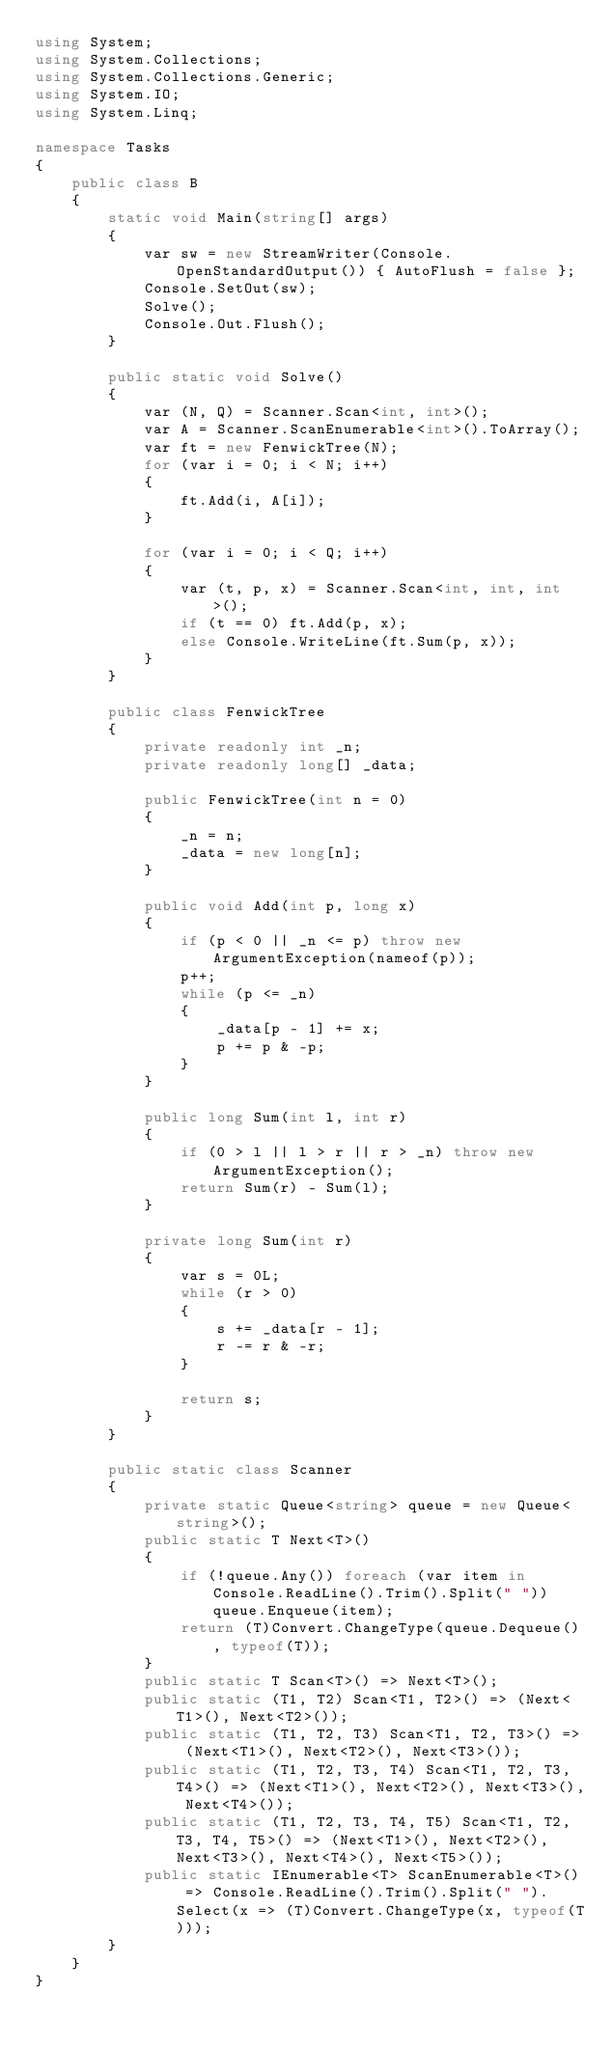<code> <loc_0><loc_0><loc_500><loc_500><_C#_>using System;
using System.Collections;
using System.Collections.Generic;
using System.IO;
using System.Linq;

namespace Tasks
{
    public class B
    {
        static void Main(string[] args)
        {
            var sw = new StreamWriter(Console.OpenStandardOutput()) { AutoFlush = false };
            Console.SetOut(sw);
            Solve();
            Console.Out.Flush();
        }

        public static void Solve()
        {
            var (N, Q) = Scanner.Scan<int, int>();
            var A = Scanner.ScanEnumerable<int>().ToArray();
            var ft = new FenwickTree(N);
            for (var i = 0; i < N; i++)
            {
                ft.Add(i, A[i]);
            }

            for (var i = 0; i < Q; i++)
            {
                var (t, p, x) = Scanner.Scan<int, int, int>();
                if (t == 0) ft.Add(p, x);
                else Console.WriteLine(ft.Sum(p, x));
            }
        }

        public class FenwickTree
        {
            private readonly int _n;
            private readonly long[] _data;

            public FenwickTree(int n = 0)
            {
                _n = n;
                _data = new long[n];
            }

            public void Add(int p, long x)
            {
                if (p < 0 || _n <= p) throw new ArgumentException(nameof(p));
                p++;
                while (p <= _n)
                {
                    _data[p - 1] += x;
                    p += p & -p;
                }
            }

            public long Sum(int l, int r)
            {
                if (0 > l || l > r || r > _n) throw new ArgumentException();
                return Sum(r) - Sum(l);
            }

            private long Sum(int r)
            {
                var s = 0L;
                while (r > 0)
                {
                    s += _data[r - 1];
                    r -= r & -r;
                }

                return s;
            }
        }

        public static class Scanner
        {
            private static Queue<string> queue = new Queue<string>();
            public static T Next<T>()
            {
                if (!queue.Any()) foreach (var item in Console.ReadLine().Trim().Split(" ")) queue.Enqueue(item);
                return (T)Convert.ChangeType(queue.Dequeue(), typeof(T));
            }
            public static T Scan<T>() => Next<T>();
            public static (T1, T2) Scan<T1, T2>() => (Next<T1>(), Next<T2>());
            public static (T1, T2, T3) Scan<T1, T2, T3>() => (Next<T1>(), Next<T2>(), Next<T3>());
            public static (T1, T2, T3, T4) Scan<T1, T2, T3, T4>() => (Next<T1>(), Next<T2>(), Next<T3>(), Next<T4>());
            public static (T1, T2, T3, T4, T5) Scan<T1, T2, T3, T4, T5>() => (Next<T1>(), Next<T2>(), Next<T3>(), Next<T4>(), Next<T5>());
            public static IEnumerable<T> ScanEnumerable<T>() => Console.ReadLine().Trim().Split(" ").Select(x => (T)Convert.ChangeType(x, typeof(T)));
        }
    }
}
</code> 